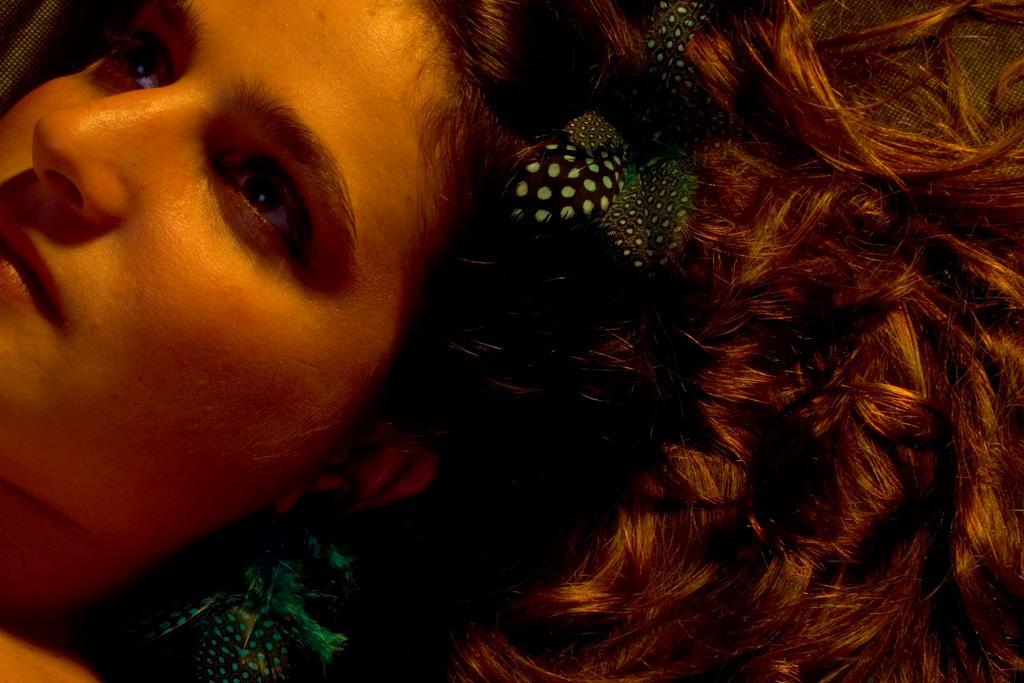Can you describe this image briefly? In this image we can see a person's face and objects on the hair. 